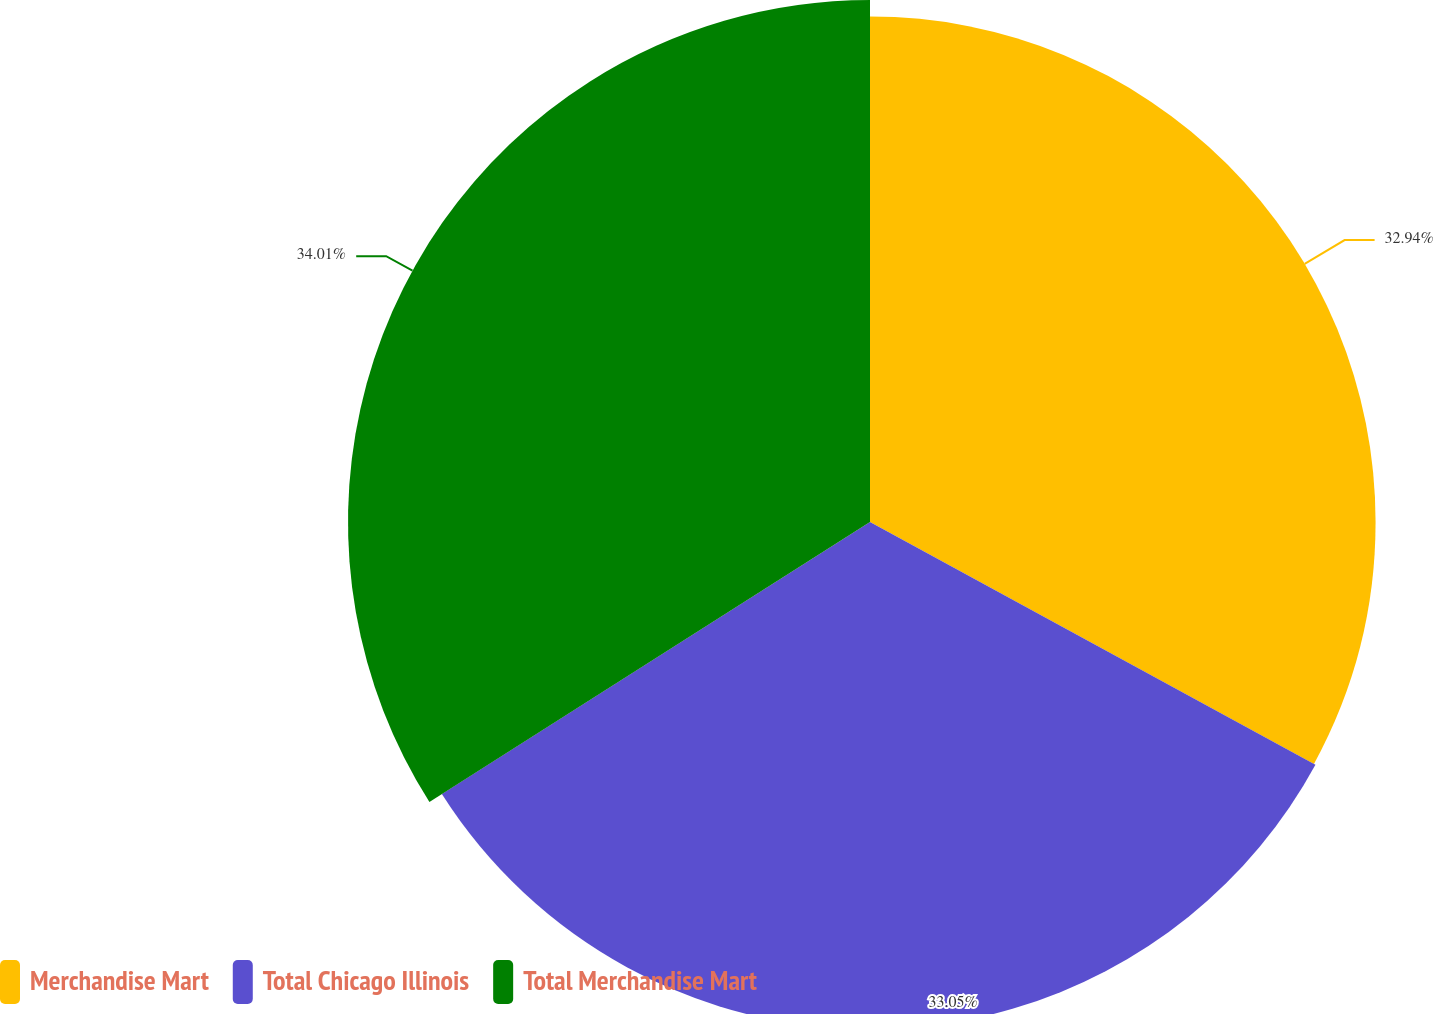Convert chart. <chart><loc_0><loc_0><loc_500><loc_500><pie_chart><fcel>Merchandise Mart<fcel>Total Chicago Illinois<fcel>Total Merchandise Mart<nl><fcel>32.94%<fcel>33.05%<fcel>34.01%<nl></chart> 